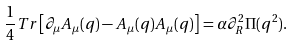Convert formula to latex. <formula><loc_0><loc_0><loc_500><loc_500>\frac { 1 } { 4 } T r \left [ \partial _ { \mu } A _ { \mu } ( q ) - A _ { \mu } ( q ) A _ { \mu } ( q ) \right ] = \alpha \partial _ { R } ^ { 2 } \Pi ( q ^ { 2 } ) .</formula> 